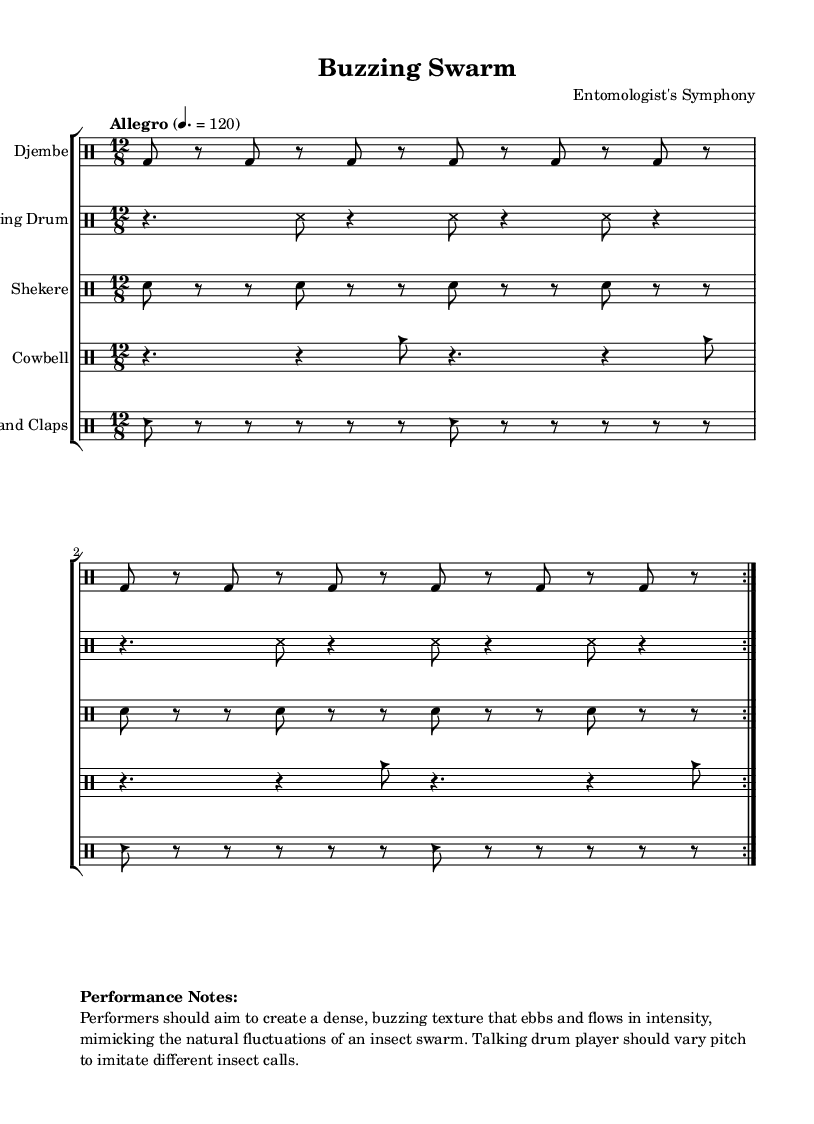What is the time signature of this piece? The time signature is 12/8, indicated at the beginning of the piece. This means there are 12 eighth notes in each measure, organizing the rhythm into a compound time signature.
Answer: 12/8 What tempo marking is given? The tempo marking in the sheet music is "Allegro," which indicates a fast tempo typically around 120 beats per minute. This is specified alongside the marking, indicating how lively the piece should be played.
Answer: Allegro How many instruments are featured in this score? There are 5 distinct instruments featured in the score: Djembe, Talking Drum, Shekere, Cowbell, and Hand Claps. Each instrument is kept in a separate staff to allow individual performance clarity.
Answer: 5 What rhythmic pattern is used for the Djembe? The rhythmic pattern for the Djembe consists of repeated bass drum hits (bd) interspersed with rests (r), maintaining a consistent and dense texture through the two repeated sections.
Answer: Bass-D drum pattern How should the Talking Drum vary during performance? The performance notes instruct that the Talking Drum player should vary the pitch to imitate different insect calls, reflecting the nature of an insect swarm that includes a variation in sound.
Answer: Vary pitch What is the main intention behind the composition based on performance notes? The main intention is to create a dense, buzzing texture that ebbs and flows in intensity, mimicking the natural fluctuations of an insect swarm. This understanding is derived from the detailed performance notes included in the score.
Answer: Mimic insect swarms 